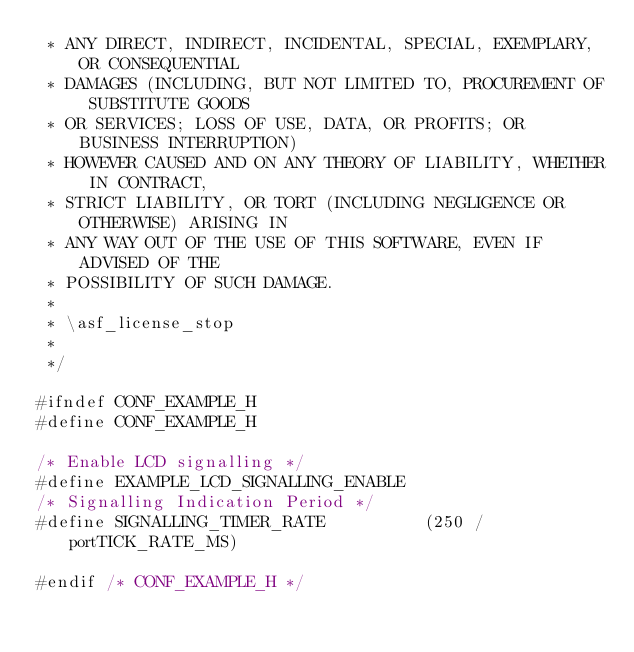Convert code to text. <code><loc_0><loc_0><loc_500><loc_500><_C_> * ANY DIRECT, INDIRECT, INCIDENTAL, SPECIAL, EXEMPLARY, OR CONSEQUENTIAL
 * DAMAGES (INCLUDING, BUT NOT LIMITED TO, PROCUREMENT OF SUBSTITUTE GOODS
 * OR SERVICES; LOSS OF USE, DATA, OR PROFITS; OR BUSINESS INTERRUPTION)
 * HOWEVER CAUSED AND ON ANY THEORY OF LIABILITY, WHETHER IN CONTRACT,
 * STRICT LIABILITY, OR TORT (INCLUDING NEGLIGENCE OR OTHERWISE) ARISING IN
 * ANY WAY OUT OF THE USE OF THIS SOFTWARE, EVEN IF ADVISED OF THE
 * POSSIBILITY OF SUCH DAMAGE.
 *
 * \asf_license_stop
 *
 */

#ifndef CONF_EXAMPLE_H
#define CONF_EXAMPLE_H

/* Enable LCD signalling */
#define EXAMPLE_LCD_SIGNALLING_ENABLE
/* Signalling Indication Period */
#define SIGNALLING_TIMER_RATE          (250 / portTICK_RATE_MS)

#endif /* CONF_EXAMPLE_H */
</code> 